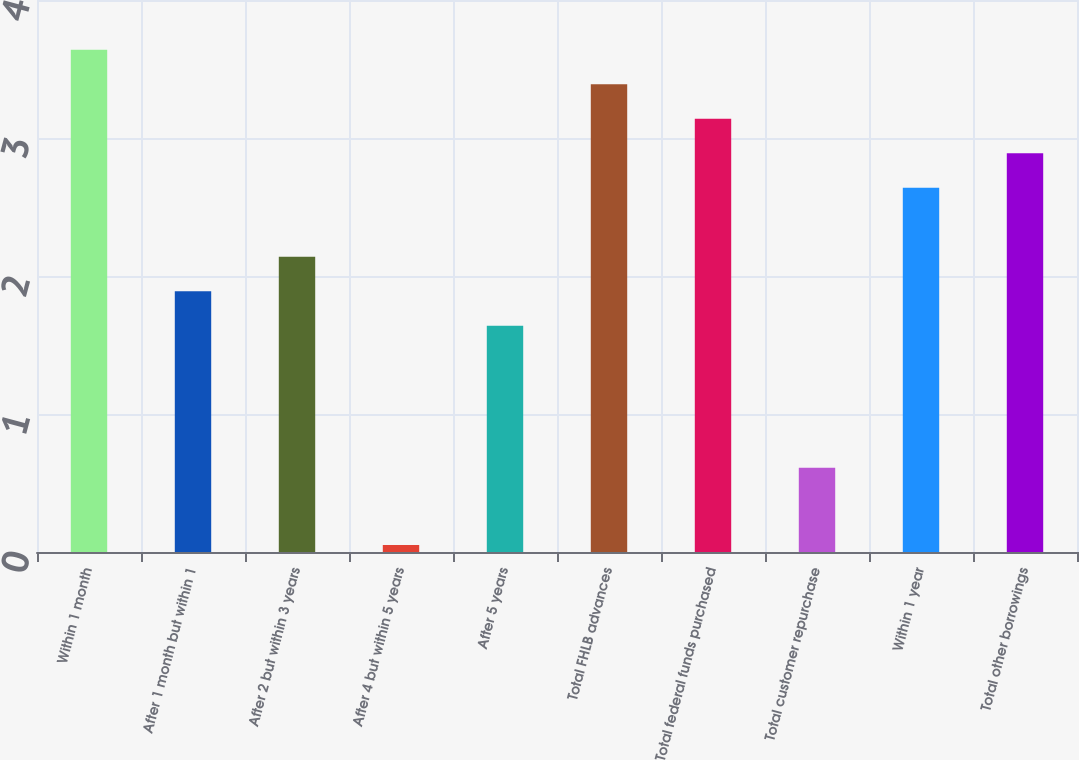Convert chart. <chart><loc_0><loc_0><loc_500><loc_500><bar_chart><fcel>Within 1 month<fcel>After 1 month but within 1<fcel>After 2 but within 3 years<fcel>After 4 but within 5 years<fcel>After 5 years<fcel>Total FHLB advances<fcel>Total federal funds purchased<fcel>Total customer repurchase<fcel>Within 1 year<fcel>Total other borrowings<nl><fcel>3.64<fcel>1.89<fcel>2.14<fcel>0.05<fcel>1.64<fcel>3.39<fcel>3.14<fcel>0.61<fcel>2.64<fcel>2.89<nl></chart> 